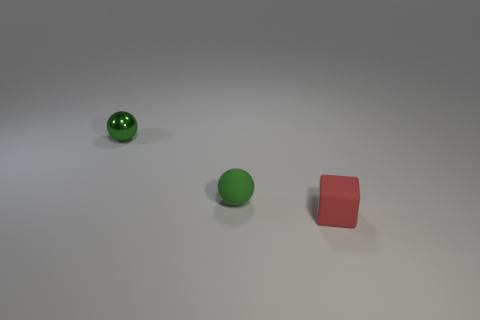How many green spheres must be subtracted to get 1 green spheres? 1 Subtract all yellow blocks. Subtract all purple balls. How many blocks are left? 1 Add 2 small matte blocks. How many objects exist? 5 Subtract all balls. How many objects are left? 1 Add 2 large cyan shiny blocks. How many large cyan shiny blocks exist? 2 Subtract 2 green balls. How many objects are left? 1 Subtract all small green shiny objects. Subtract all tiny green metal objects. How many objects are left? 1 Add 2 small blocks. How many small blocks are left? 3 